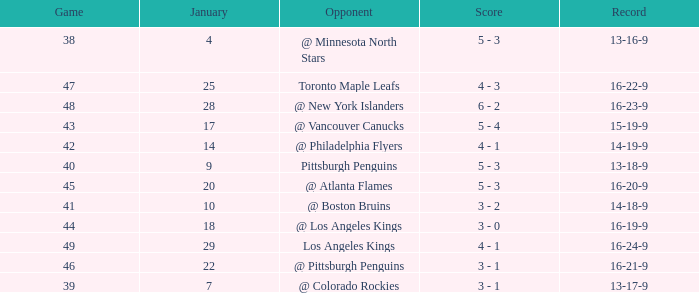What was the record after the game before Jan 7? 13-16-9. 